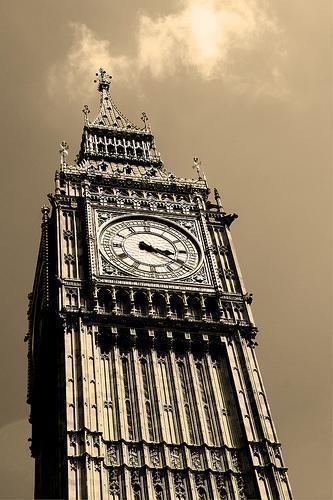How many clock faces are seen in this photo?
Give a very brief answer. 1. 